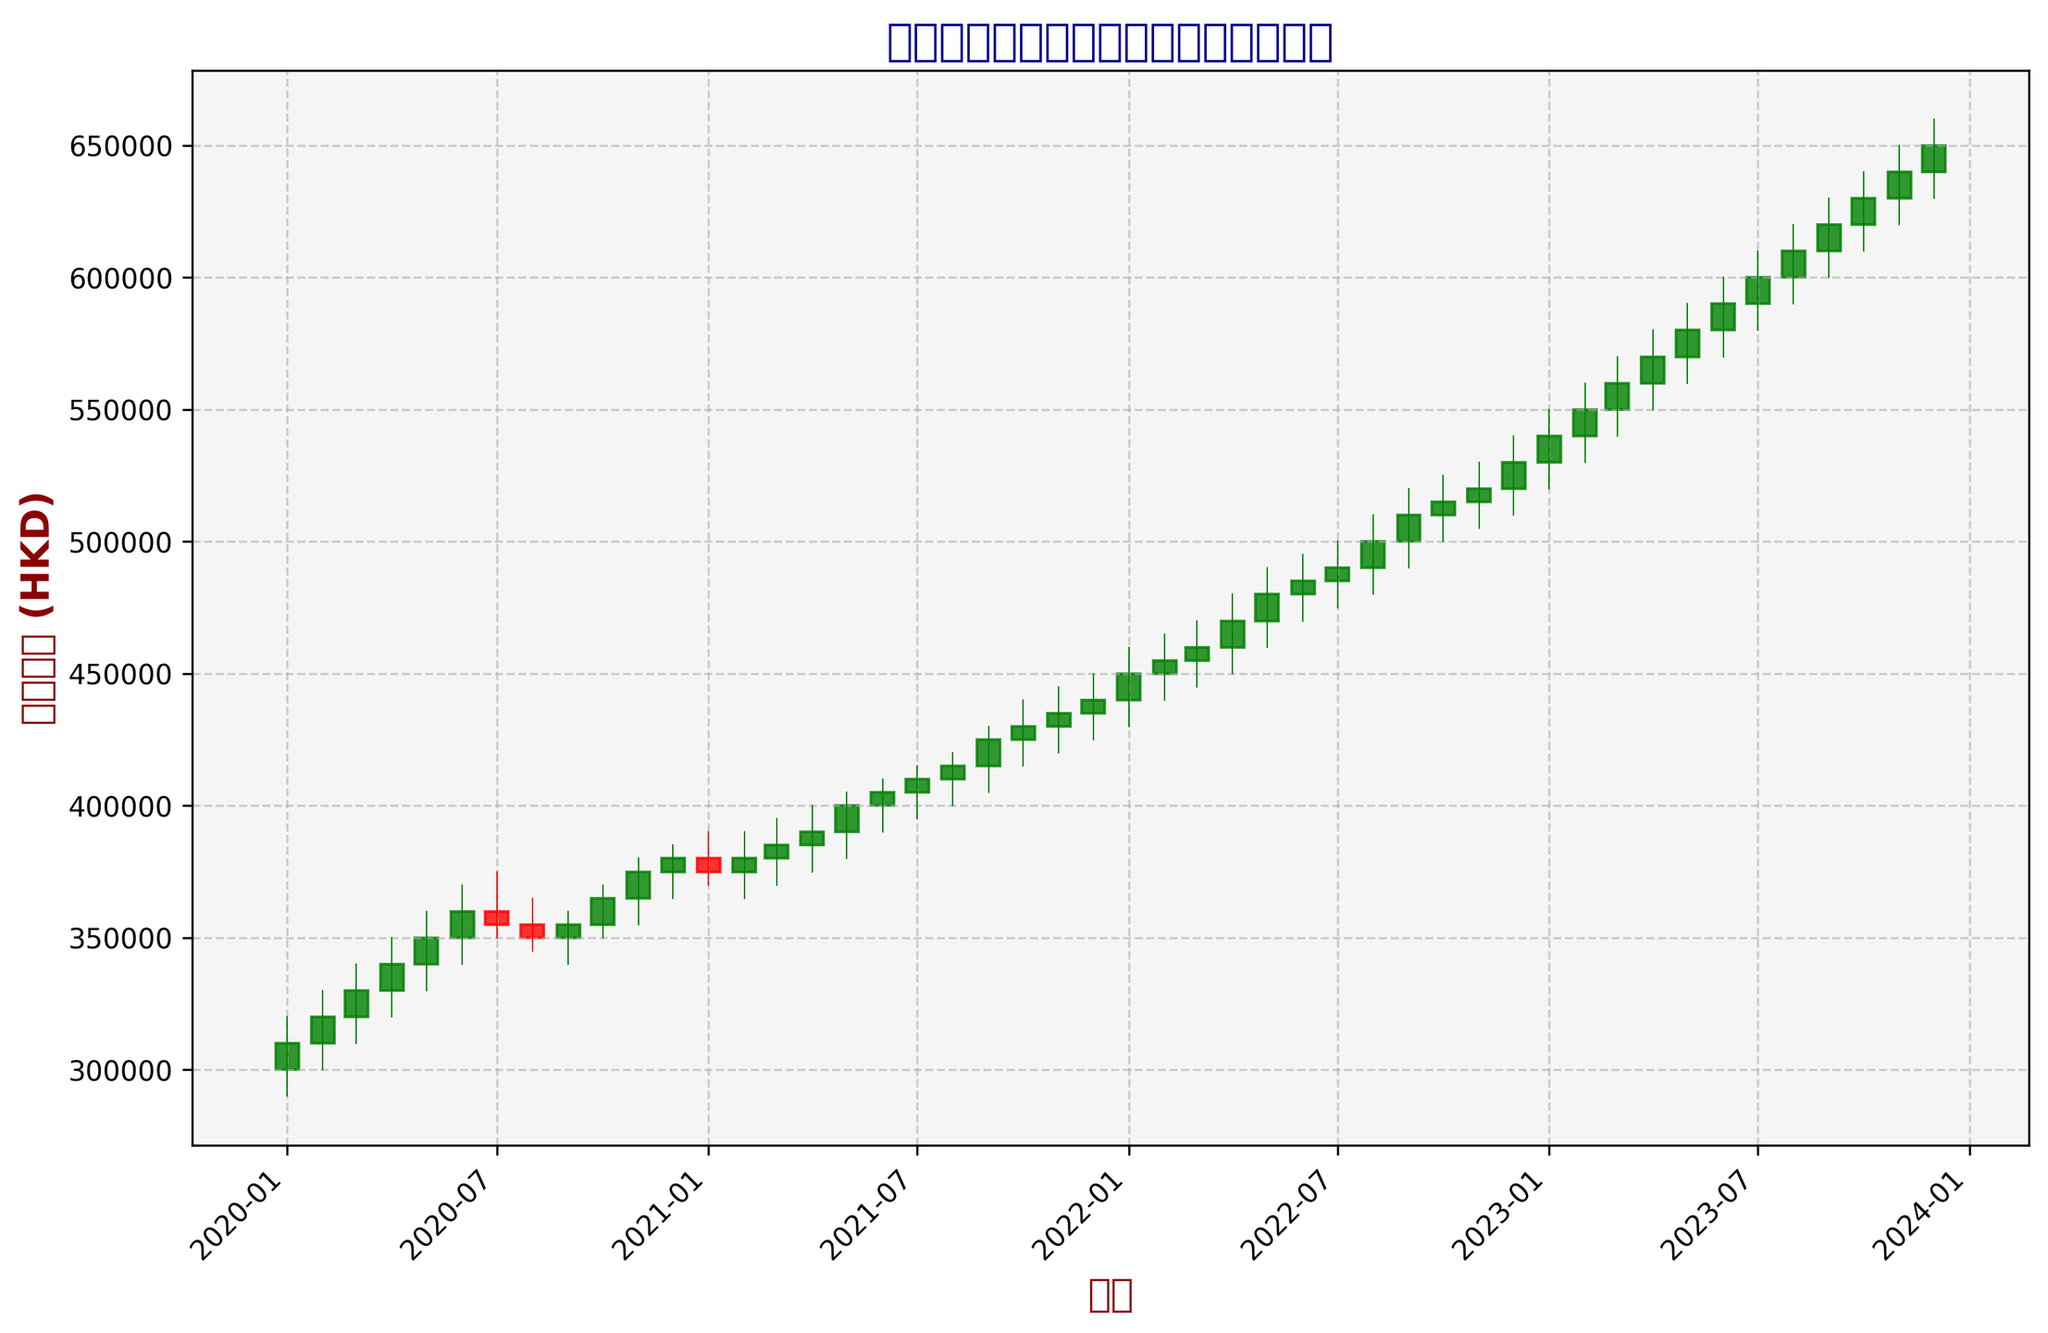Which month had the highest peak in the box office revenue during the observed period? Look at the highest 'High' value in the candlestick chart. The peak occurred in some months between 2020 and 2023. The highest point is in December 2023.
Answer: December 2023 How does the closing price in December 2020 compare to the closing price in December 2023? Refer to the 'Close' value in December 2020 and December 2023 on the x-axis of the candlestick chart. In December 2020, the closing price was 380,000 HKD, and in December 2023, it was 650,000 HKD. The closing price in December 2023 is higher by 270,000 HKD.
Answer: Higher by 270,000 HKD Which two months have the most significant change in box office revenue? Identify the two months with the largest difference between 'Open' and 'Close', or the most substantial change in the candlestick chart. The months with significant changes are October 2023 (high closing) and July 2022 or November 2020 (lower closing but significant change).
Answer: October 2023 and July 2022 What is the trend observed in the box office revenue from January 2020 to January 2023? Analyze the general movement direction of the candlestick chart from January 2020 to January 2023. The trend shows a steady increase as the box office revenue consistently flows upward over this period.
Answer: Steady Increase By how much did the box office revenue grow from January 2020 to January 2023? Check the 'Close' value in January 2020 (310,000 HKD) and January 2023 (540,000 HKD). Subtract the initial value from the final value: 540,000 - 310,000 = 230,000 HKD.
Answer: 230,000 HKD What is the average closing value for the entire dataset period? Sum all 'Close' values and divide by the number of observations (48). The total sum of closing values from the data is 19,550,000 HKD. To find the average: 19,550,000 / 48 = 407,291.67 HKD.
Answer: 407,291.67 HKD Identify the month where the box office revenue fell compared to the previous month during the 2023 data. Track the 'Close' values for each month in the year 2023. Check if a month's closing value is lower than the previous month's. For instance, June 2023 (590,000 HKD) after May 2023 (580,000 HKD) showing a decrease.
Answer: June 2023 How did the box office revenue in May 2022 (480,000 HKD) compare to May 2023 (580,000 HKD)? Look at the 'Close' values for May in both 2022 and 2023 in the chart. There was a growth of 100,000 HKD from 480,000 HKD in 2022 to 580,000 HKD in 2023.
Answer: Increased by 100,000 HKD 